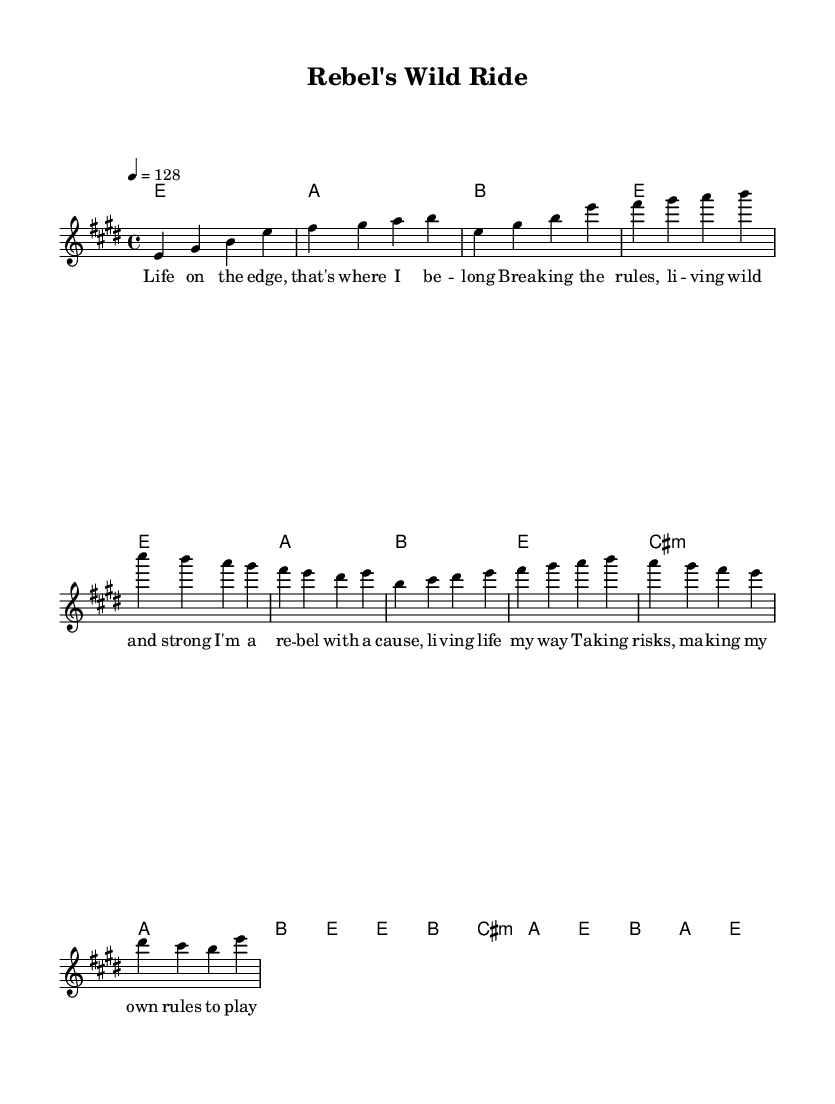What is the key signature of this music? The key signature is E major, which has four sharps: F sharp, C sharp, G sharp, and D sharp.
Answer: E major What is the time signature of this music? The time signature is 4/4, which indicates that there are four beats in a measure and the quarter note gets one beat.
Answer: 4/4 What is the tempo marking of the music? The tempo marking indicates a speed of 128 beats per minute, which is noted above the staff as "4 = 128".
Answer: 128 How many measures are in the chorus section? The chorus consists of four measures, as identified by the specific melodic and harmonic lines that repeat and correspond to the lyrics of the chorus.
Answer: 4 What are the first two notes of the melody? The first two notes of the melody are E and G sharp, which are the initial pitches in the introduction, indicated clearly in the notation.
Answer: E, G sharp What is the dynamic character of the overall piece? Although not explicitly indicated in the provided code, the tempo and the energetic structure of both the melody and harmony suggest a lively and assertive dynamic character traditionally found in rock anthems.
Answer: Lively What type of song structure does this piece follow? The song primarily follows a verse-chorus structure, as indicated by the distinct sections labeled for the verse and chorus lyrics.
Answer: Verse-chorus 